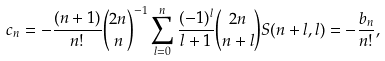Convert formula to latex. <formula><loc_0><loc_0><loc_500><loc_500>c _ { n } = - \frac { ( n + 1 ) } { n ! } { 2 n \choose n } ^ { - 1 } \sum _ { l = 0 } ^ { n } \frac { ( - 1 ) ^ { l } } { l + 1 } { 2 n \choose n + l } S ( n + l , l ) = - \frac { b _ { n } } { n ! } ,</formula> 